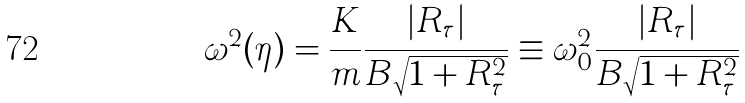Convert formula to latex. <formula><loc_0><loc_0><loc_500><loc_500>\omega ^ { 2 } ( \eta ) = \frac { K } { m } \frac { | R _ { \tau } | } { B \sqrt { 1 + R _ { \tau } ^ { 2 } } } \equiv \omega _ { 0 } ^ { 2 } \frac { | R _ { \tau } | } { B \sqrt { 1 + R _ { \tau } ^ { 2 } } }</formula> 